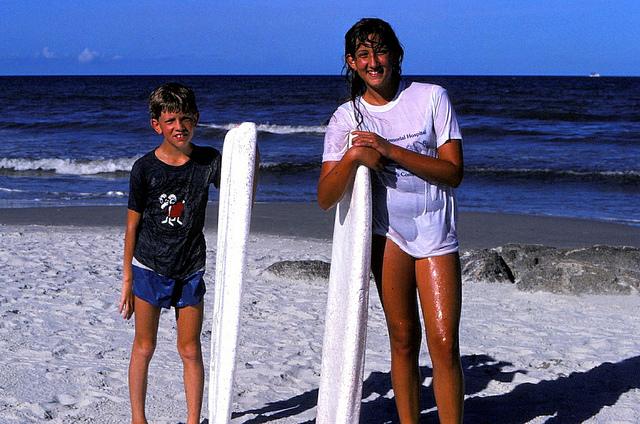Is there sand?
Answer briefly. Yes. Did they just come back from surfing?
Write a very short answer. Yes. Are there any wild animals in this picture?
Be succinct. No. 